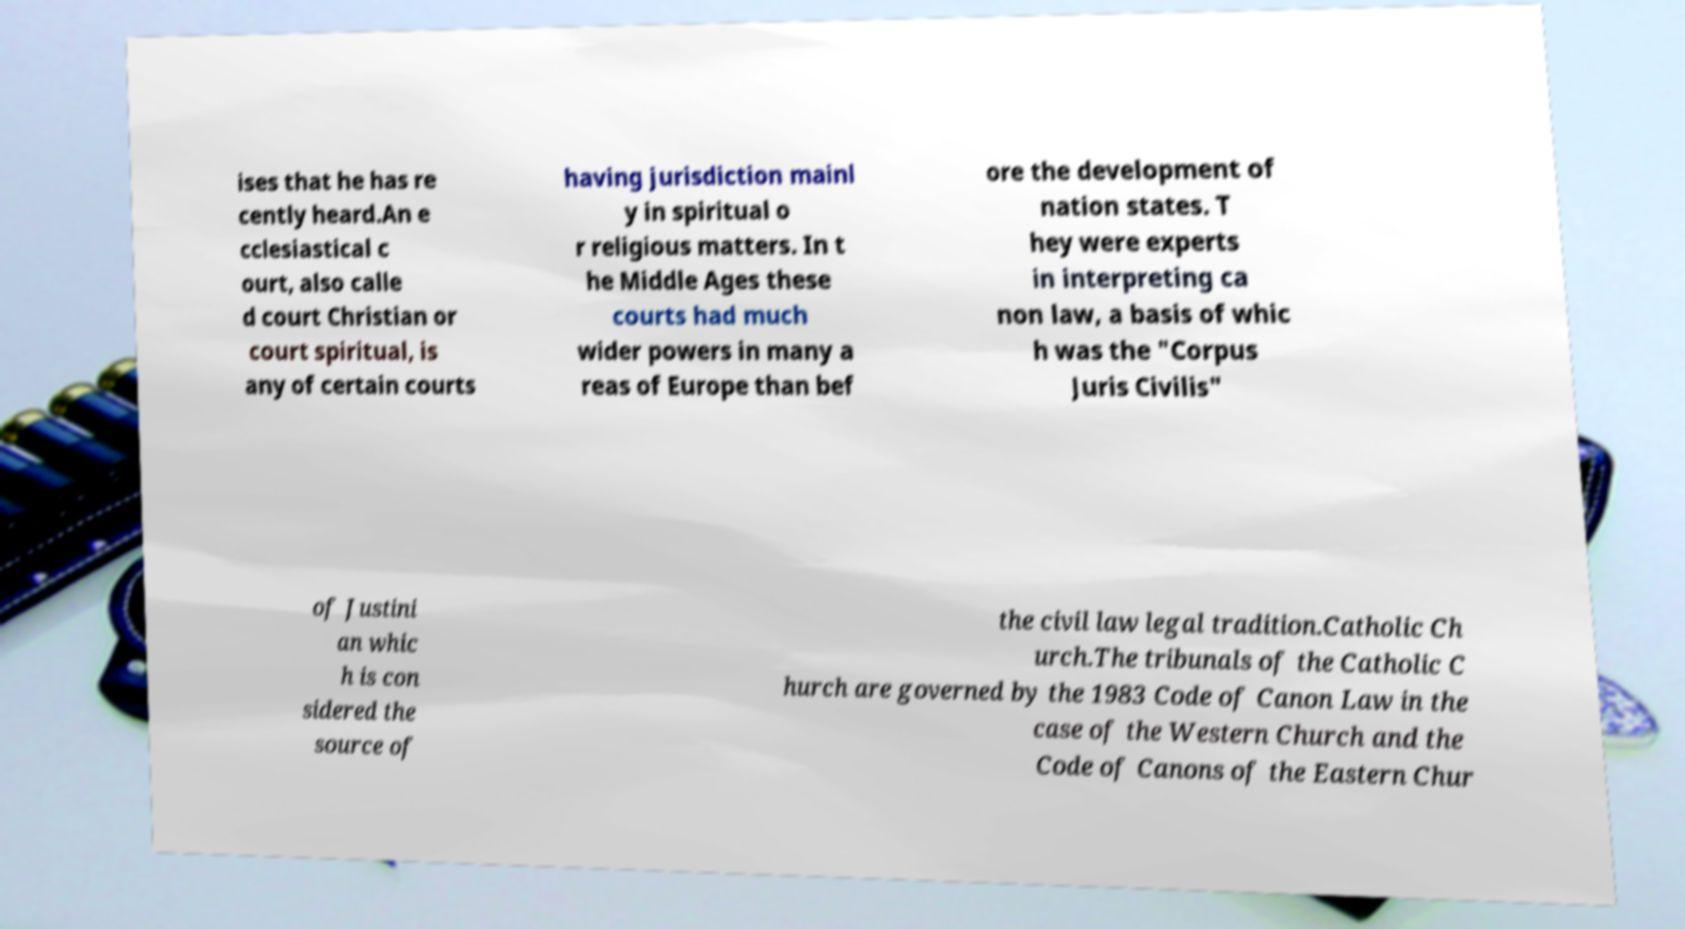Please identify and transcribe the text found in this image. ises that he has re cently heard.An e cclesiastical c ourt, also calle d court Christian or court spiritual, is any of certain courts having jurisdiction mainl y in spiritual o r religious matters. In t he Middle Ages these courts had much wider powers in many a reas of Europe than bef ore the development of nation states. T hey were experts in interpreting ca non law, a basis of whic h was the "Corpus Juris Civilis" of Justini an whic h is con sidered the source of the civil law legal tradition.Catholic Ch urch.The tribunals of the Catholic C hurch are governed by the 1983 Code of Canon Law in the case of the Western Church and the Code of Canons of the Eastern Chur 